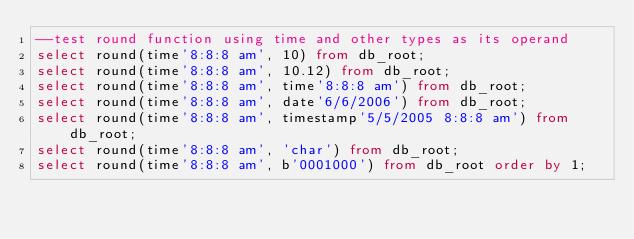Convert code to text. <code><loc_0><loc_0><loc_500><loc_500><_SQL_>--test round function using time and other types as its operand
select round(time'8:8:8 am', 10) from db_root;
select round(time'8:8:8 am', 10.12) from db_root;
select round(time'8:8:8 am', time'8:8:8 am') from db_root;
select round(time'8:8:8 am', date'6/6/2006') from db_root;
select round(time'8:8:8 am', timestamp'5/5/2005 8:8:8 am') from db_root;
select round(time'8:8:8 am', 'char') from db_root;
select round(time'8:8:8 am', b'0001000') from db_root order by 1;</code> 